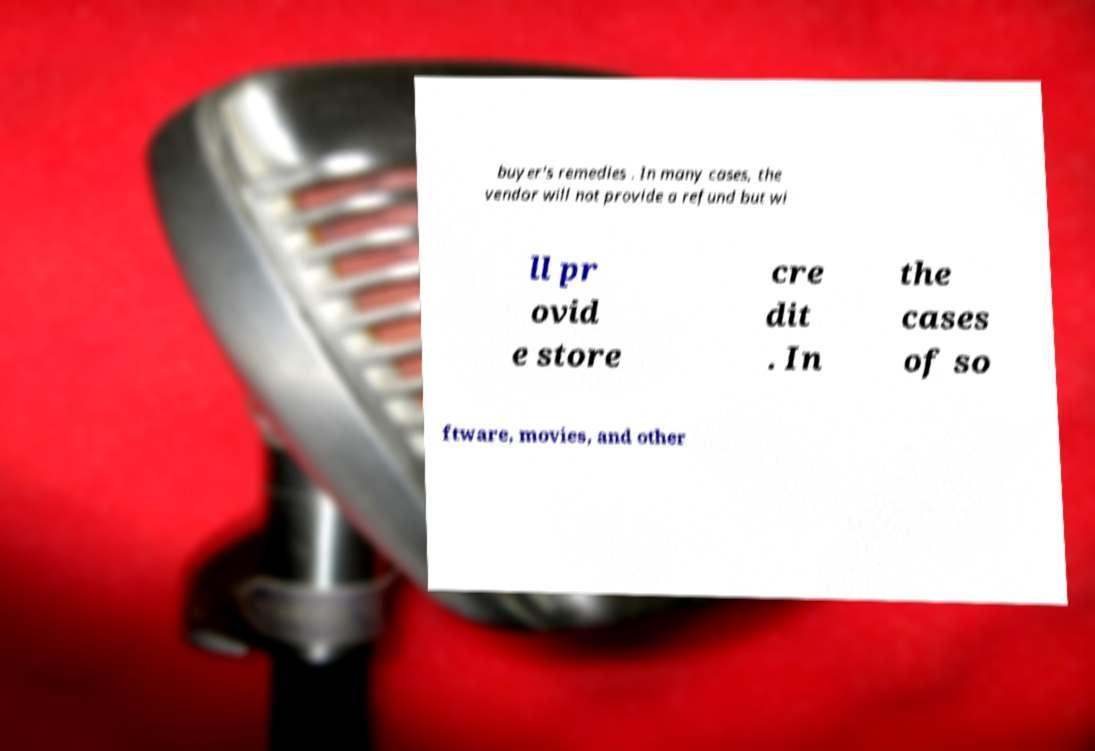I need the written content from this picture converted into text. Can you do that? buyer's remedies . In many cases, the vendor will not provide a refund but wi ll pr ovid e store cre dit . In the cases of so ftware, movies, and other 